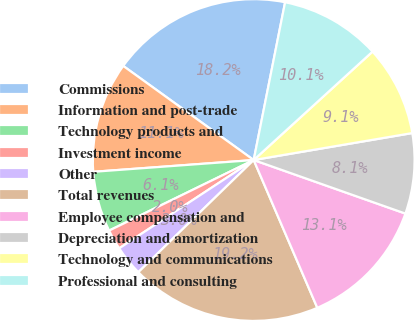Convert chart. <chart><loc_0><loc_0><loc_500><loc_500><pie_chart><fcel>Commissions<fcel>Information and post-trade<fcel>Technology products and<fcel>Investment income<fcel>Other<fcel>Total revenues<fcel>Employee compensation and<fcel>Depreciation and amortization<fcel>Technology and communications<fcel>Professional and consulting<nl><fcel>18.18%<fcel>11.11%<fcel>6.06%<fcel>2.02%<fcel>3.03%<fcel>19.19%<fcel>13.13%<fcel>8.08%<fcel>9.09%<fcel>10.1%<nl></chart> 